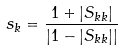<formula> <loc_0><loc_0><loc_500><loc_500>s _ { k } = \frac { 1 + | S _ { k k } | } { | 1 - | S _ { k k } | | }</formula> 